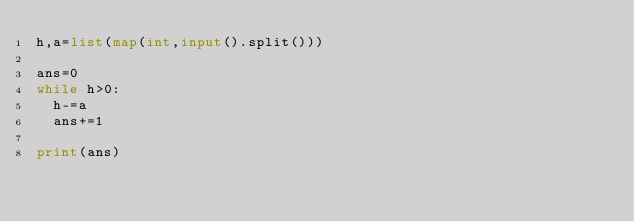<code> <loc_0><loc_0><loc_500><loc_500><_Python_>h,a=list(map(int,input().split()))

ans=0
while h>0:
  h-=a
  ans+=1

print(ans)
</code> 